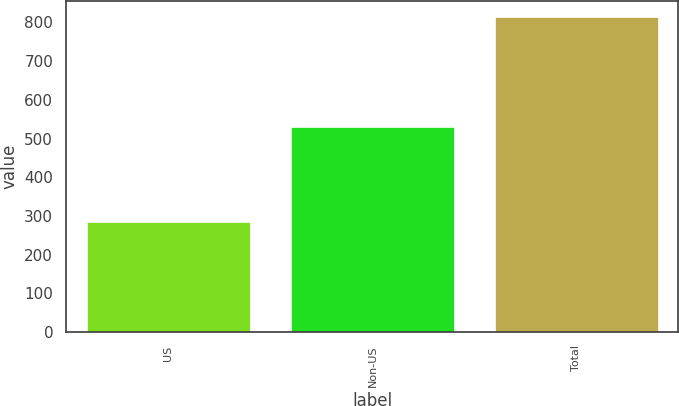Convert chart. <chart><loc_0><loc_0><loc_500><loc_500><bar_chart><fcel>US<fcel>Non-US<fcel>Total<nl><fcel>284<fcel>530<fcel>814<nl></chart> 